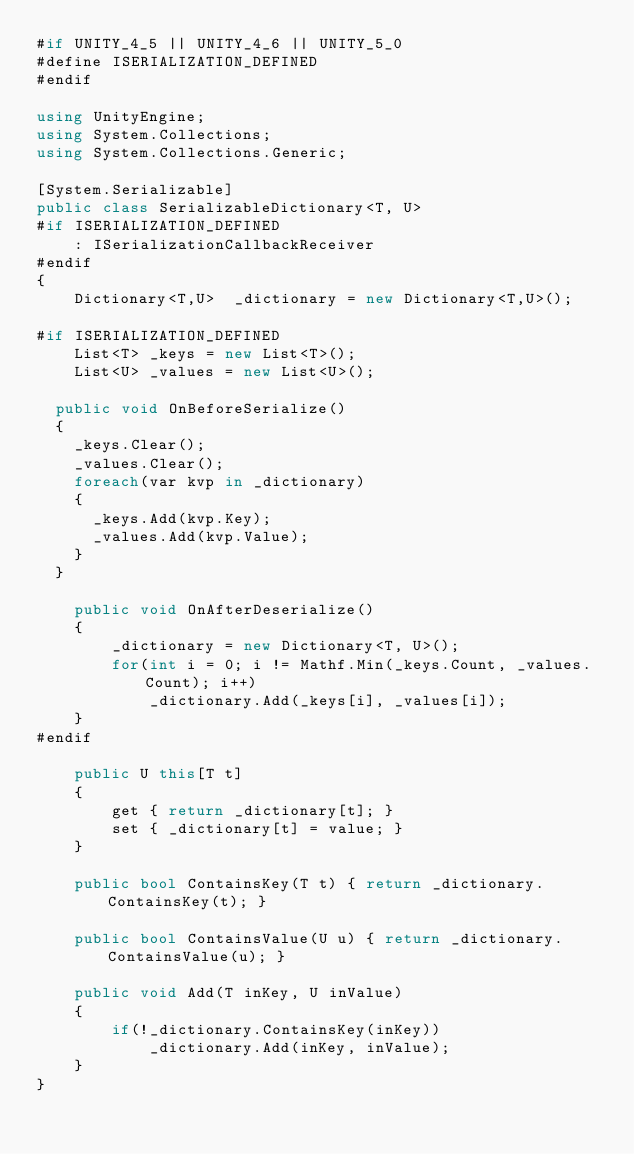<code> <loc_0><loc_0><loc_500><loc_500><_C#_>#if UNITY_4_5 || UNITY_4_6 || UNITY_5_0
#define ISERIALIZATION_DEFINED
#endif

using UnityEngine;
using System.Collections;
using System.Collections.Generic;

[System.Serializable]
public class SerializableDictionary<T, U>
#if ISERIALIZATION_DEFINED
    : ISerializationCallbackReceiver
#endif
{
    Dictionary<T,U>  _dictionary = new Dictionary<T,U>();
    
#if ISERIALIZATION_DEFINED
    List<T> _keys = new List<T>();
    List<U> _values = new List<U>();

	public void OnBeforeSerialize()
	{
		_keys.Clear();
		_values.Clear();
		foreach(var kvp in _dictionary)
		{
			_keys.Add(kvp.Key);
			_values.Add(kvp.Value);
		}
	}

    public void OnAfterDeserialize()
    {
        _dictionary = new Dictionary<T, U>();
        for(int i = 0; i != Mathf.Min(_keys.Count, _values.Count); i++)
            _dictionary.Add(_keys[i], _values[i]);
    }
#endif

    public U this[T t]
    {
        get { return _dictionary[t]; }
        set { _dictionary[t] = value; }
    }

    public bool ContainsKey(T t) { return _dictionary.ContainsKey(t); }

    public bool ContainsValue(U u) { return _dictionary.ContainsValue(u); }

    public void Add(T inKey, U inValue)
    {
        if(!_dictionary.ContainsKey(inKey))
            _dictionary.Add(inKey, inValue);
    }
}
</code> 